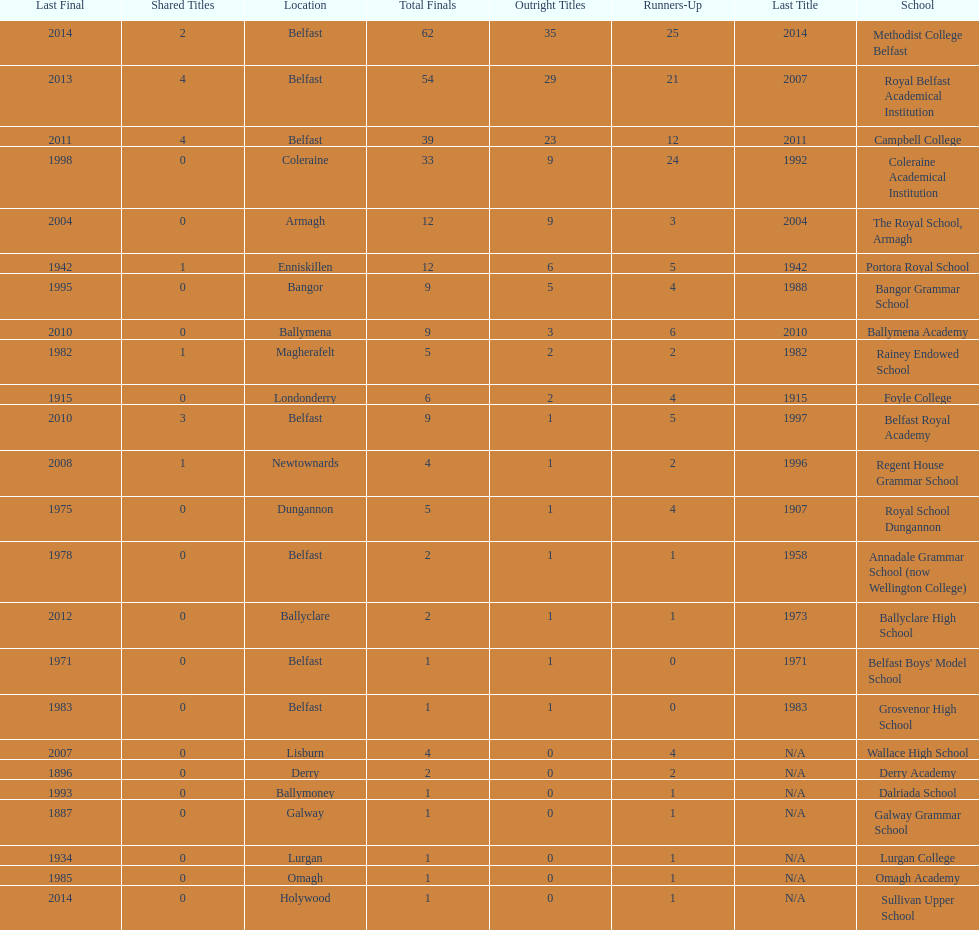What number of total finals does foyle college have? 6. 